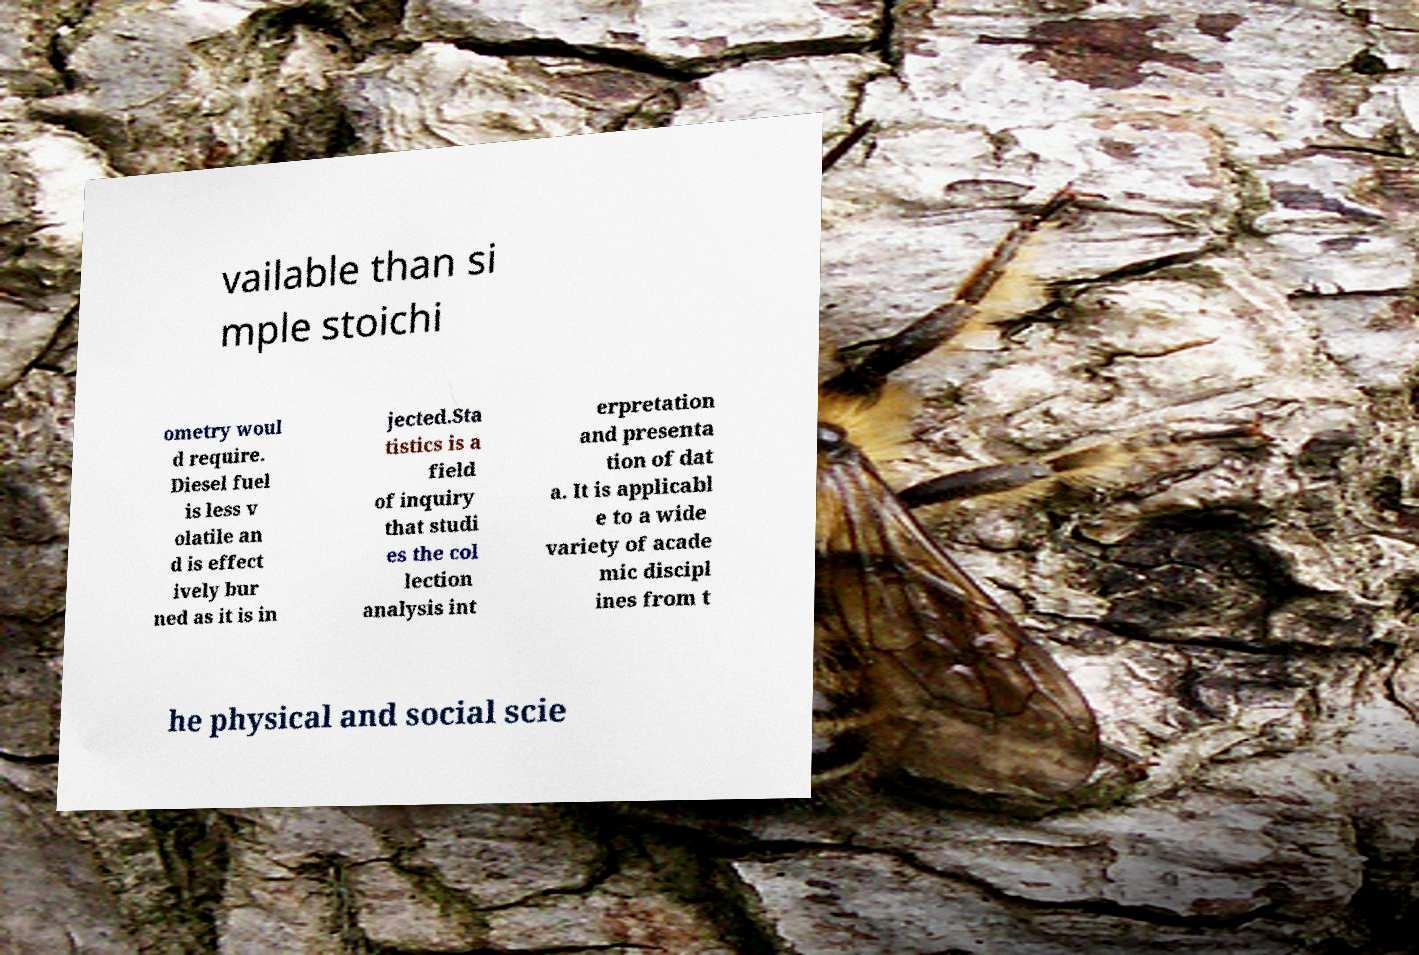Can you accurately transcribe the text from the provided image for me? vailable than si mple stoichi ometry woul d require. Diesel fuel is less v olatile an d is effect ively bur ned as it is in jected.Sta tistics is a field of inquiry that studi es the col lection analysis int erpretation and presenta tion of dat a. It is applicabl e to a wide variety of acade mic discipl ines from t he physical and social scie 